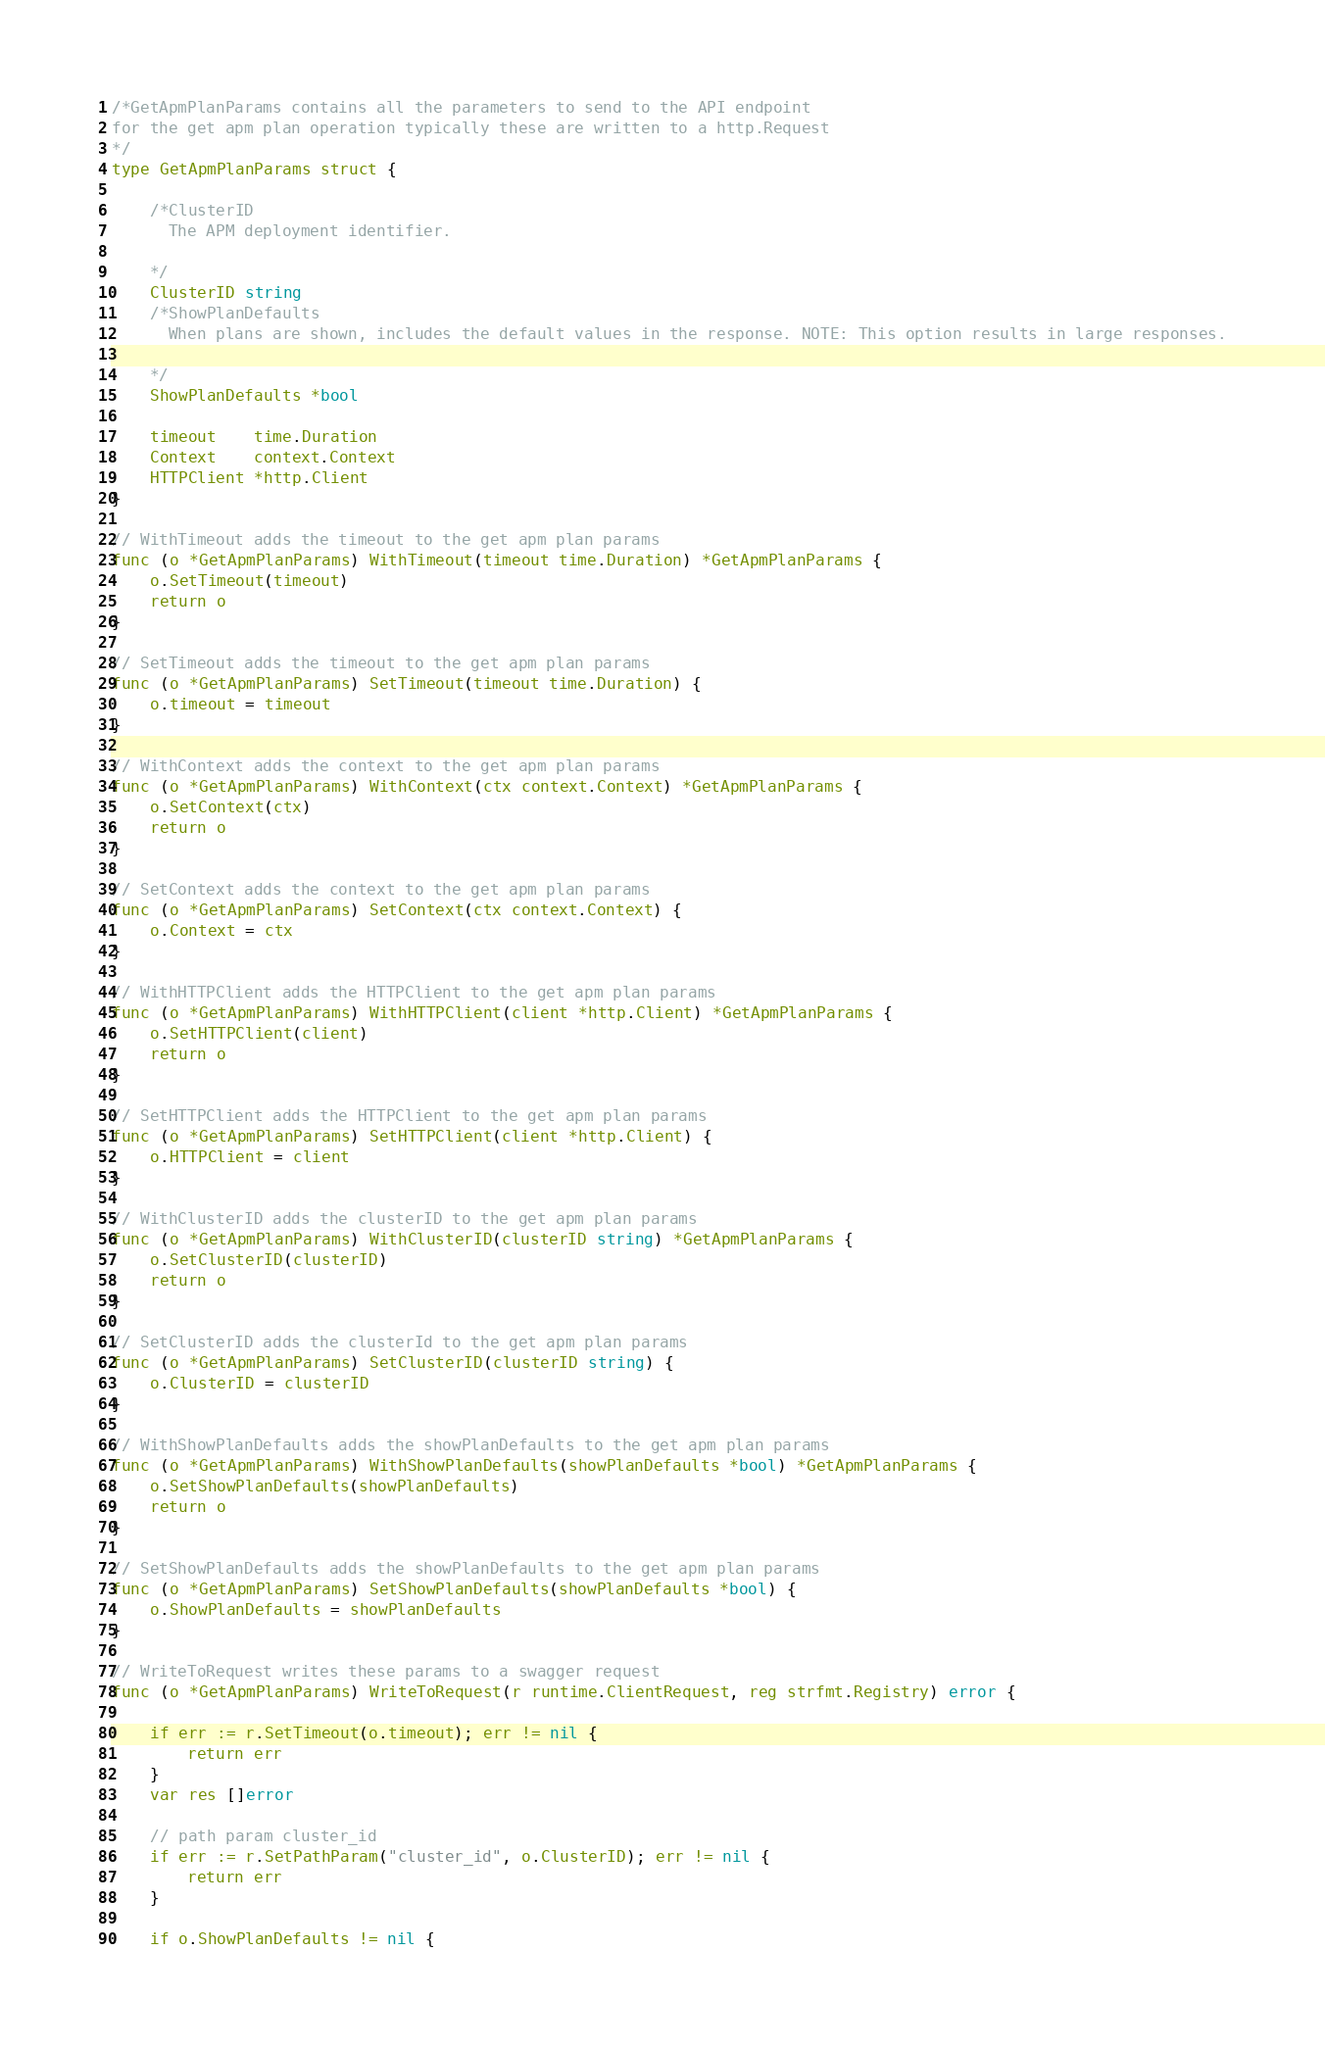<code> <loc_0><loc_0><loc_500><loc_500><_Go_>
/*GetApmPlanParams contains all the parameters to send to the API endpoint
for the get apm plan operation typically these are written to a http.Request
*/
type GetApmPlanParams struct {

	/*ClusterID
	  The APM deployment identifier.

	*/
	ClusterID string
	/*ShowPlanDefaults
	  When plans are shown, includes the default values in the response. NOTE: This option results in large responses.

	*/
	ShowPlanDefaults *bool

	timeout    time.Duration
	Context    context.Context
	HTTPClient *http.Client
}

// WithTimeout adds the timeout to the get apm plan params
func (o *GetApmPlanParams) WithTimeout(timeout time.Duration) *GetApmPlanParams {
	o.SetTimeout(timeout)
	return o
}

// SetTimeout adds the timeout to the get apm plan params
func (o *GetApmPlanParams) SetTimeout(timeout time.Duration) {
	o.timeout = timeout
}

// WithContext adds the context to the get apm plan params
func (o *GetApmPlanParams) WithContext(ctx context.Context) *GetApmPlanParams {
	o.SetContext(ctx)
	return o
}

// SetContext adds the context to the get apm plan params
func (o *GetApmPlanParams) SetContext(ctx context.Context) {
	o.Context = ctx
}

// WithHTTPClient adds the HTTPClient to the get apm plan params
func (o *GetApmPlanParams) WithHTTPClient(client *http.Client) *GetApmPlanParams {
	o.SetHTTPClient(client)
	return o
}

// SetHTTPClient adds the HTTPClient to the get apm plan params
func (o *GetApmPlanParams) SetHTTPClient(client *http.Client) {
	o.HTTPClient = client
}

// WithClusterID adds the clusterID to the get apm plan params
func (o *GetApmPlanParams) WithClusterID(clusterID string) *GetApmPlanParams {
	o.SetClusterID(clusterID)
	return o
}

// SetClusterID adds the clusterId to the get apm plan params
func (o *GetApmPlanParams) SetClusterID(clusterID string) {
	o.ClusterID = clusterID
}

// WithShowPlanDefaults adds the showPlanDefaults to the get apm plan params
func (o *GetApmPlanParams) WithShowPlanDefaults(showPlanDefaults *bool) *GetApmPlanParams {
	o.SetShowPlanDefaults(showPlanDefaults)
	return o
}

// SetShowPlanDefaults adds the showPlanDefaults to the get apm plan params
func (o *GetApmPlanParams) SetShowPlanDefaults(showPlanDefaults *bool) {
	o.ShowPlanDefaults = showPlanDefaults
}

// WriteToRequest writes these params to a swagger request
func (o *GetApmPlanParams) WriteToRequest(r runtime.ClientRequest, reg strfmt.Registry) error {

	if err := r.SetTimeout(o.timeout); err != nil {
		return err
	}
	var res []error

	// path param cluster_id
	if err := r.SetPathParam("cluster_id", o.ClusterID); err != nil {
		return err
	}

	if o.ShowPlanDefaults != nil {
</code> 